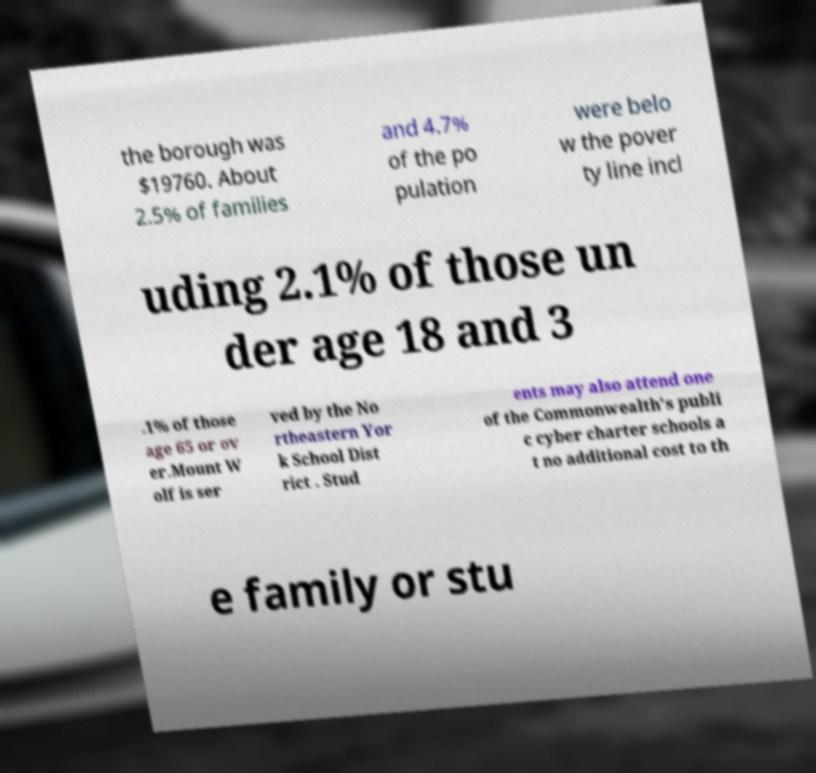Could you assist in decoding the text presented in this image and type it out clearly? the borough was $19760. About 2.5% of families and 4.7% of the po pulation were belo w the pover ty line incl uding 2.1% of those un der age 18 and 3 .1% of those age 65 or ov er.Mount W olf is ser ved by the No rtheastern Yor k School Dist rict . Stud ents may also attend one of the Commonwealth's publi c cyber charter schools a t no additional cost to th e family or stu 